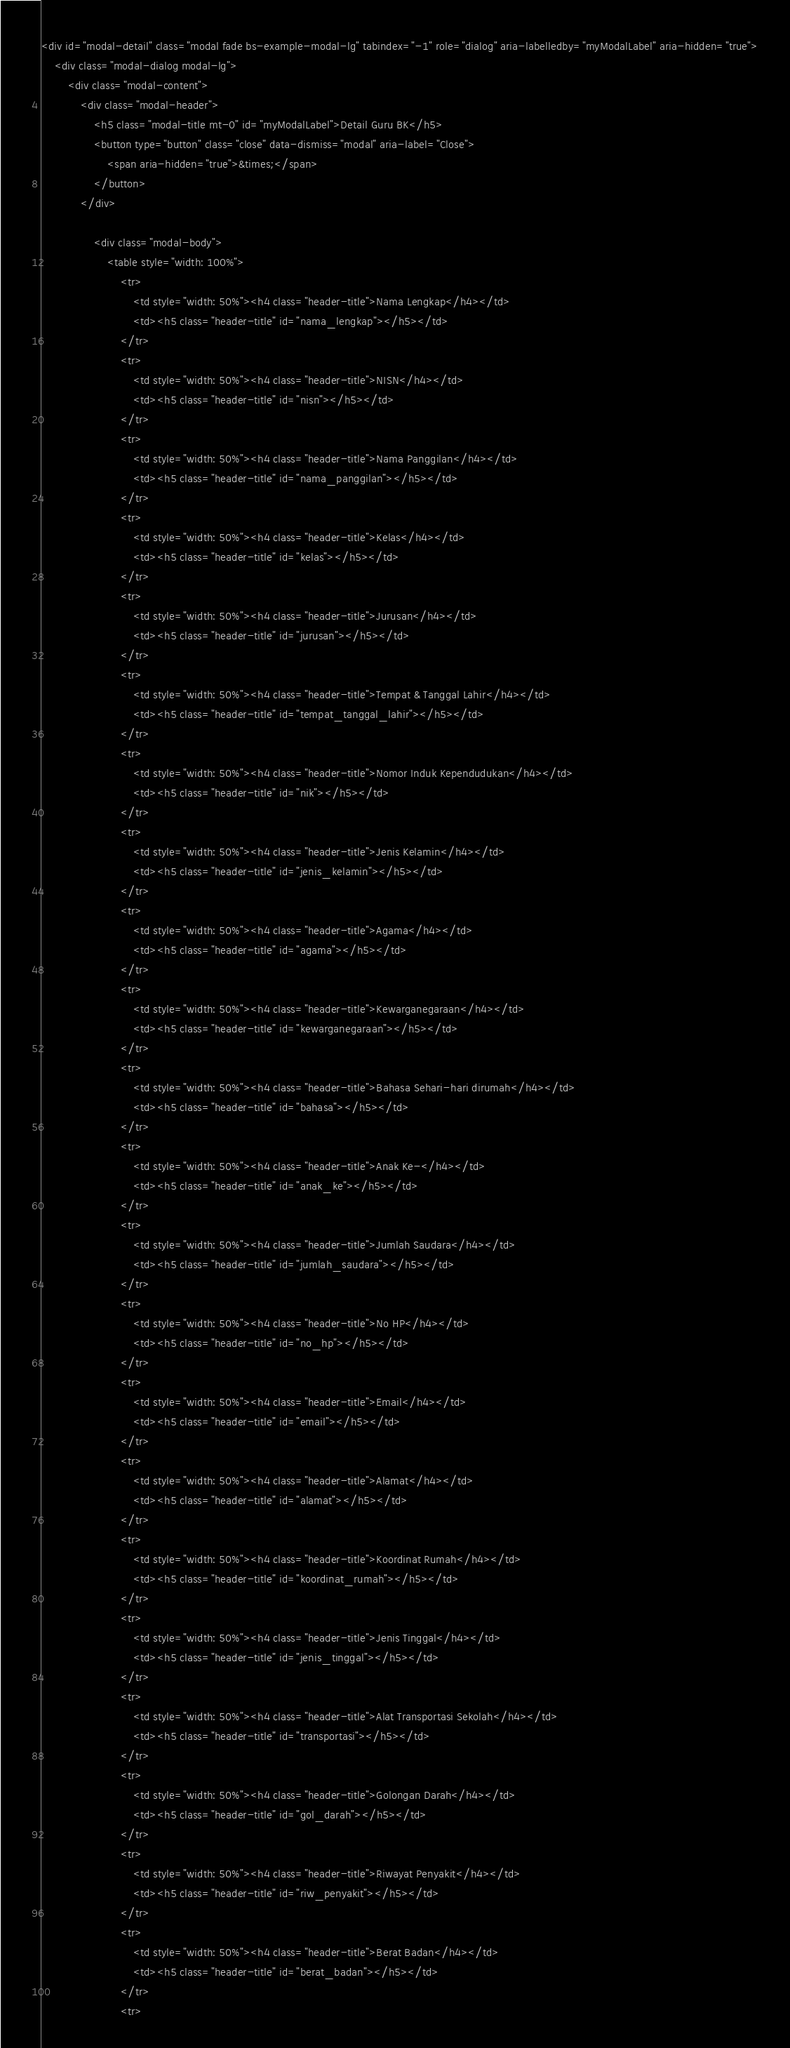Convert code to text. <code><loc_0><loc_0><loc_500><loc_500><_PHP_><div id="modal-detail" class="modal fade bs-example-modal-lg" tabindex="-1" role="dialog" aria-labelledby="myModalLabel" aria-hidden="true">
    <div class="modal-dialog modal-lg">
        <div class="modal-content">
            <div class="modal-header">
                <h5 class="modal-title mt-0" id="myModalLabel">Detail Guru BK</h5>
                <button type="button" class="close" data-dismiss="modal" aria-label="Close">
                    <span aria-hidden="true">&times;</span>
                </button>
            </div>

                <div class="modal-body">
                    <table style="width: 100%">
                        <tr>
                            <td style="width: 50%"><h4 class="header-title">Nama Lengkap</h4></td>
                            <td><h5 class="header-title" id="nama_lengkap"></h5></td>
                        </tr>
                        <tr>
                            <td style="width: 50%"><h4 class="header-title">NISN</h4></td>
                            <td><h5 class="header-title" id="nisn"></h5></td>
                        </tr>
                        <tr>
                            <td style="width: 50%"><h4 class="header-title">Nama Panggilan</h4></td>
                            <td><h5 class="header-title" id="nama_panggilan"></h5></td>
                        </tr>
                        <tr>
                            <td style="width: 50%"><h4 class="header-title">Kelas</h4></td>
                            <td><h5 class="header-title" id="kelas"></h5></td>
                        </tr>
                        <tr>
                            <td style="width: 50%"><h4 class="header-title">Jurusan</h4></td>
                            <td><h5 class="header-title" id="jurusan"></h5></td>
                        </tr>
                        <tr>
                            <td style="width: 50%"><h4 class="header-title">Tempat & Tanggal Lahir</h4></td>
                            <td><h5 class="header-title" id="tempat_tanggal_lahir"></h5></td>
                        </tr>
                        <tr>
                            <td style="width: 50%"><h4 class="header-title">Nomor Induk Kependudukan</h4></td>
                            <td><h5 class="header-title" id="nik"></h5></td>
                        </tr>
                        <tr>
                            <td style="width: 50%"><h4 class="header-title">Jenis Kelamin</h4></td>
                            <td><h5 class="header-title" id="jenis_kelamin"></h5></td>
                        </tr>
                        <tr>
                            <td style="width: 50%"><h4 class="header-title">Agama</h4></td>
                            <td><h5 class="header-title" id="agama"></h5></td>
                        </tr>
                        <tr>
                            <td style="width: 50%"><h4 class="header-title">Kewarganegaraan</h4></td>
                            <td><h5 class="header-title" id="kewarganegaraan"></h5></td>
                        </tr>
                        <tr>
                            <td style="width: 50%"><h4 class="header-title">Bahasa Sehari-hari dirumah</h4></td>
                            <td><h5 class="header-title" id="bahasa"></h5></td>
                        </tr>
                        <tr>
                            <td style="width: 50%"><h4 class="header-title">Anak Ke-</h4></td>
                            <td><h5 class="header-title" id="anak_ke"></h5></td>
                        </tr>
                        <tr>
                            <td style="width: 50%"><h4 class="header-title">Jumlah Saudara</h4></td>
                            <td><h5 class="header-title" id="jumlah_saudara"></h5></td>
                        </tr>
                        <tr>
                            <td style="width: 50%"><h4 class="header-title">No HP</h4></td>
                            <td><h5 class="header-title" id="no_hp"></h5></td>
                        </tr>
                        <tr>
                            <td style="width: 50%"><h4 class="header-title">Email</h4></td>
                            <td><h5 class="header-title" id="email"></h5></td>
                        </tr>
                        <tr>
                            <td style="width: 50%"><h4 class="header-title">Alamat</h4></td>
                            <td><h5 class="header-title" id="alamat"></h5></td>
                        </tr>
                        <tr>
                            <td style="width: 50%"><h4 class="header-title">Koordinat Rumah</h4></td>
                            <td><h5 class="header-title" id="koordinat_rumah"></h5></td>
                        </tr>
                        <tr>
                            <td style="width: 50%"><h4 class="header-title">Jenis Tinggal</h4></td>
                            <td><h5 class="header-title" id="jenis_tinggal"></h5></td>
                        </tr>
                        <tr>
                            <td style="width: 50%"><h4 class="header-title">Alat Transportasi Sekolah</h4></td>
                            <td><h5 class="header-title" id="transportasi"></h5></td>
                        </tr>
                        <tr>
                            <td style="width: 50%"><h4 class="header-title">Golongan Darah</h4></td>
                            <td><h5 class="header-title" id="gol_darah"></h5></td>
                        </tr>
                        <tr>
                            <td style="width: 50%"><h4 class="header-title">Riwayat Penyakit</h4></td>
                            <td><h5 class="header-title" id="riw_penyakit"></h5></td>
                        </tr>
                        <tr>
                            <td style="width: 50%"><h4 class="header-title">Berat Badan</h4></td>
                            <td><h5 class="header-title" id="berat_badan"></h5></td>
                        </tr>
                        <tr></code> 